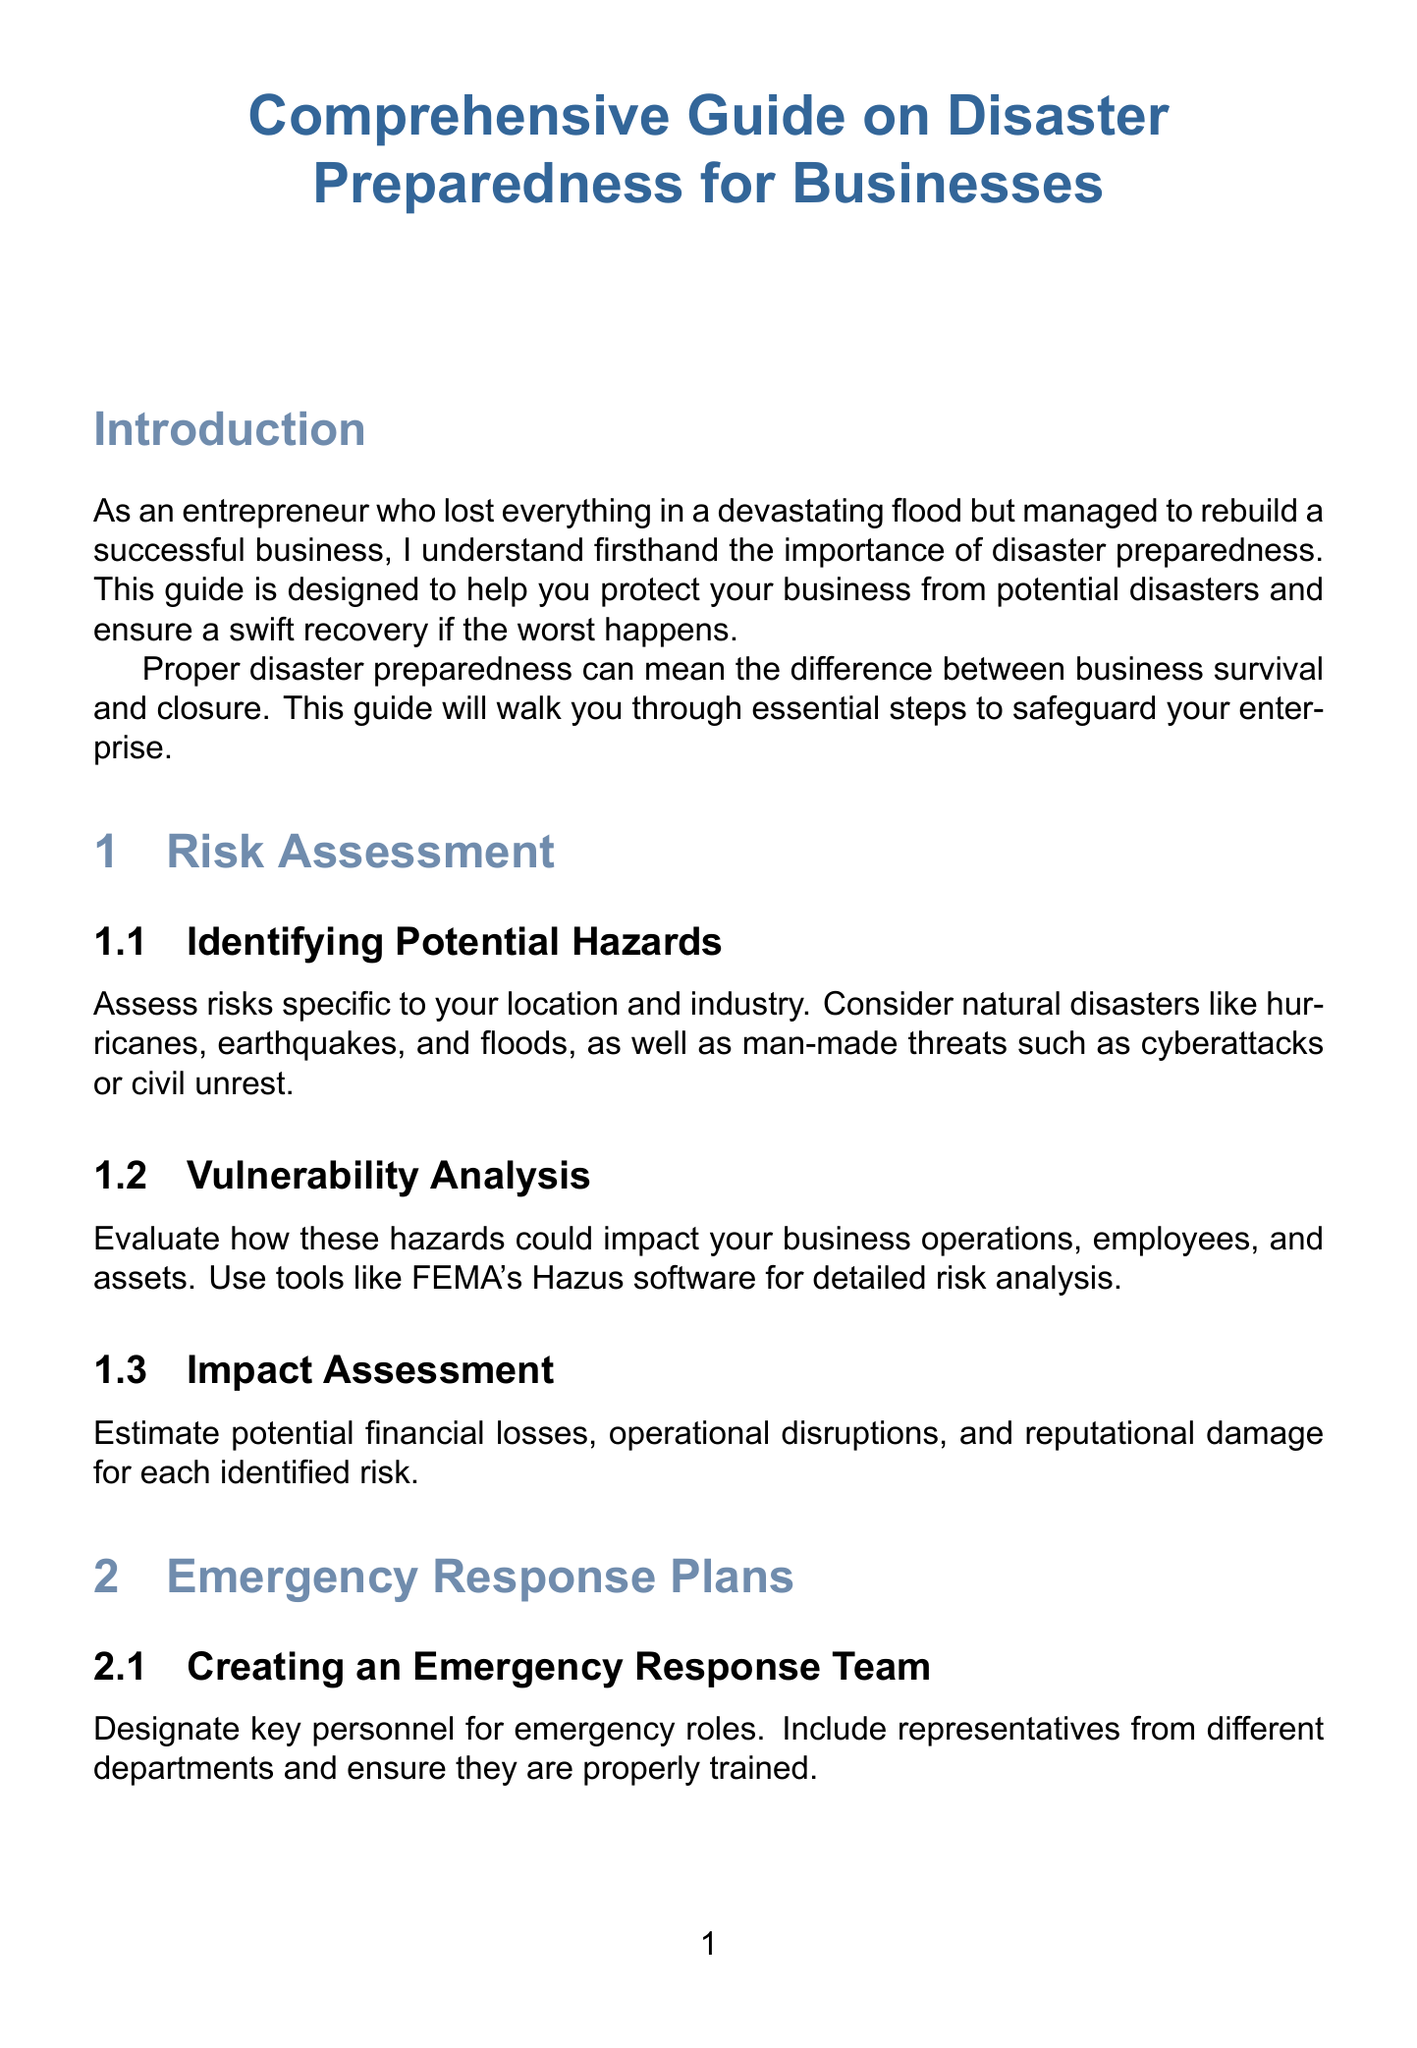what types of natural disasters should businesses consider when conducting a risk assessment? The document specifies that businesses should consider natural disasters like hurricanes, earthquakes, and floods during risk assessment.
Answer: hurricanes, earthquakes, floods what software can be used for detailed risk analysis? The guide mentions using FEMA's Hazus software for detailed risk analysis in vulnerability analysis.
Answer: FEMA's Hazus what is a recommended method for data backup? The document suggests implementing robust data backup systems, such as cloud-based solutions like Amazon Web Services or Microsoft Azure.
Answer: Amazon Web Services, Microsoft Azure what should businesses regularly review to ensure disaster preparedness? The guide recommends scheduling yearly reviews of disaster preparedness plans to maintain their current effectiveness.
Answer: yearly reviews who can provide professional disaster preparedness training? The document suggests partnering with organizations like the American Red Cross for professional training programs.
Answer: American Red Cross what is one key takeaway from the conclusion? The conclusion highlights that disaster preparedness is an ongoing process requiring vigilance and adaptability.
Answer: ongoing process how often should businesses conduct post-incident analysis? The document does not specify a frequency but indicates that a post-incident analysis should occur after any incident or near-miss.
Answer: after any incident or near-miss what type of insurance is essential for business continuity? The document lists business interruption insurance as one of the essential types of insurance for businesses.
Answer: business interruption insurance 